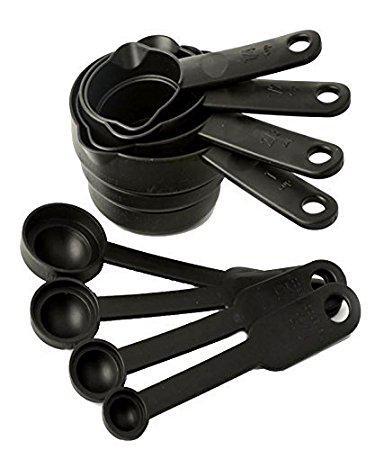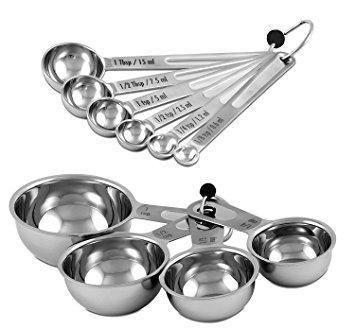The first image is the image on the left, the second image is the image on the right. Given the left and right images, does the statement "One the set of measuring spoons is white with black handles." hold true? Answer yes or no. No. 